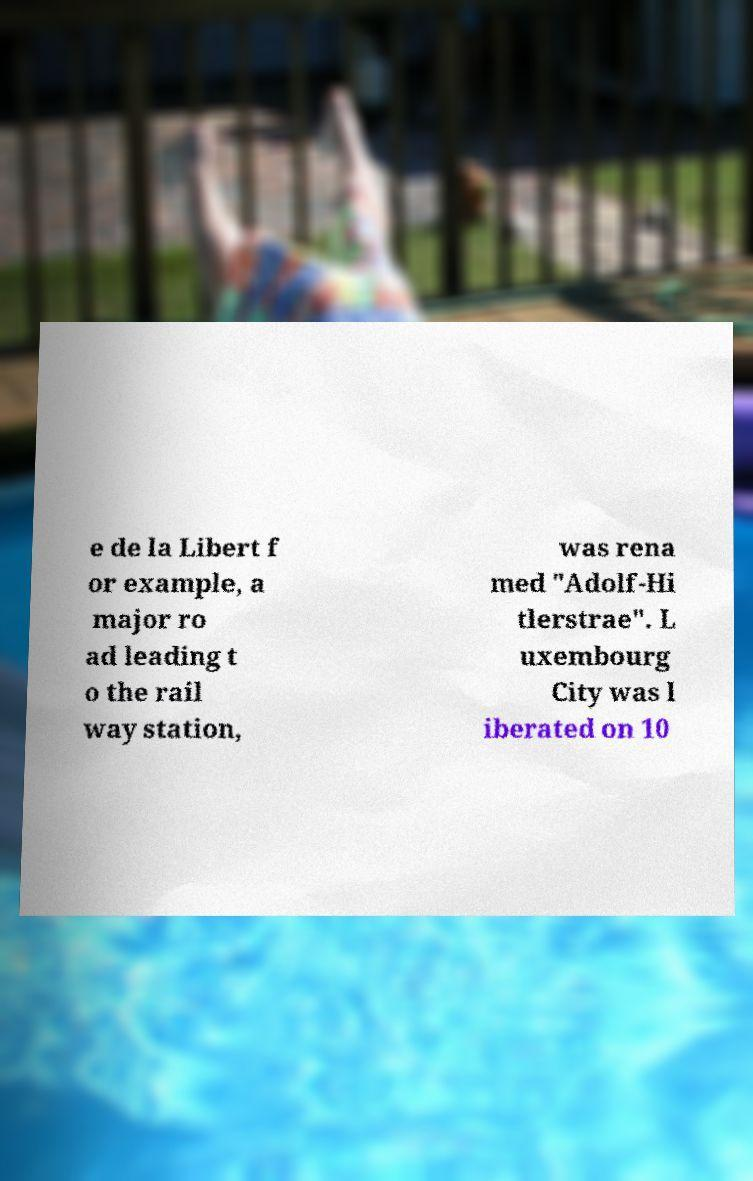Can you read and provide the text displayed in the image?This photo seems to have some interesting text. Can you extract and type it out for me? e de la Libert f or example, a major ro ad leading t o the rail way station, was rena med "Adolf-Hi tlerstrae". L uxembourg City was l iberated on 10 